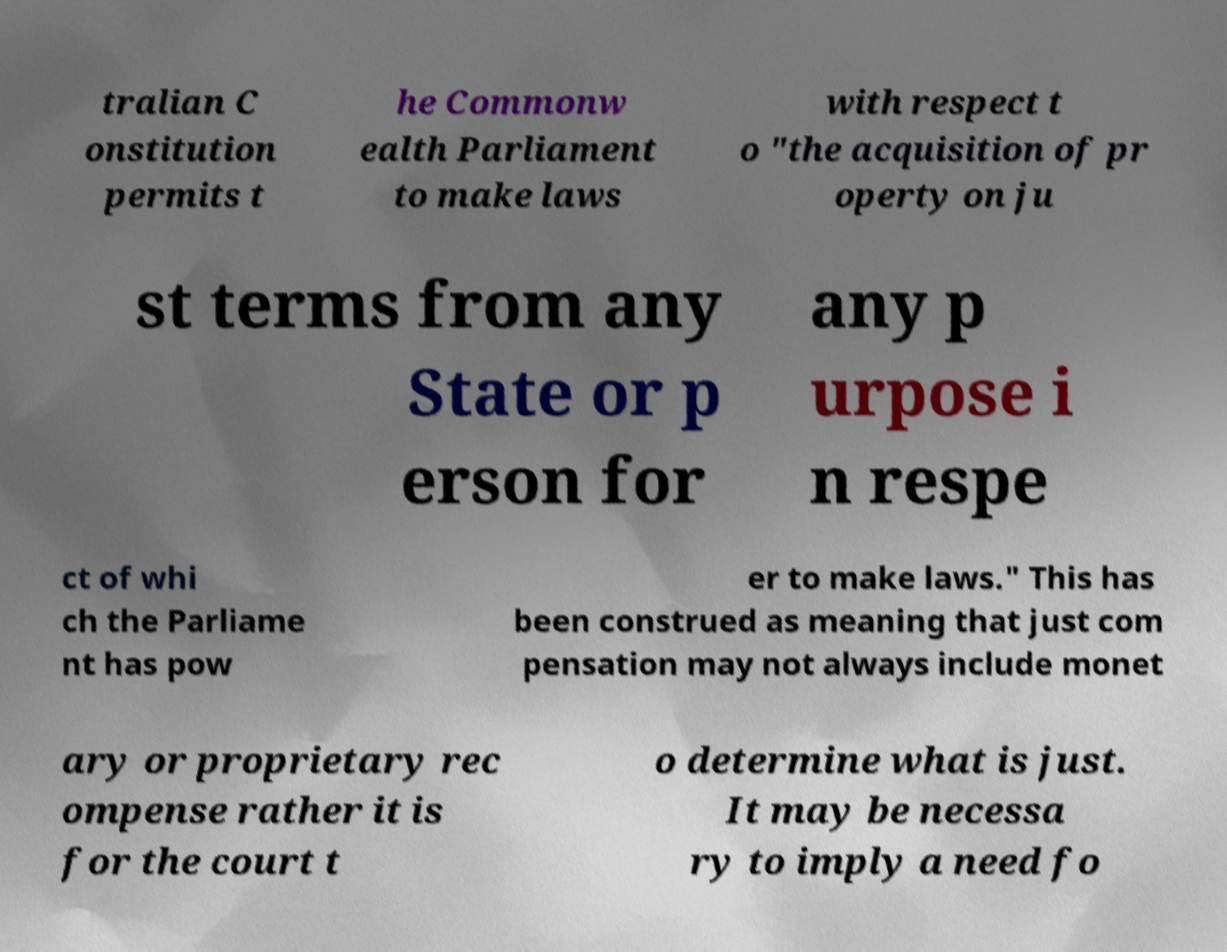What messages or text are displayed in this image? I need them in a readable, typed format. tralian C onstitution permits t he Commonw ealth Parliament to make laws with respect t o "the acquisition of pr operty on ju st terms from any State or p erson for any p urpose i n respe ct of whi ch the Parliame nt has pow er to make laws." This has been construed as meaning that just com pensation may not always include monet ary or proprietary rec ompense rather it is for the court t o determine what is just. It may be necessa ry to imply a need fo 